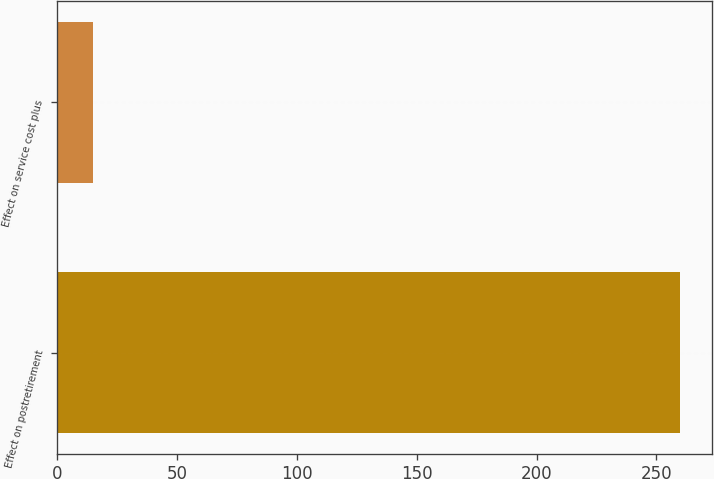Convert chart. <chart><loc_0><loc_0><loc_500><loc_500><bar_chart><fcel>Effect on postretirement<fcel>Effect on service cost plus<nl><fcel>260<fcel>15<nl></chart> 